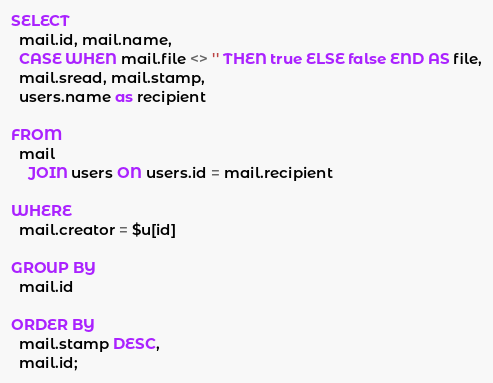<code> <loc_0><loc_0><loc_500><loc_500><_SQL_>
SELECT
  mail.id, mail.name,
  CASE WHEN mail.file <> '' THEN true ELSE false END AS file,
  mail.sread, mail.stamp,
  users.name as recipient

FROM
  mail
    JOIN users ON users.id = mail.recipient

WHERE
  mail.creator = $u[id]

GROUP BY
  mail.id

ORDER BY
  mail.stamp DESC,
  mail.id;</code> 